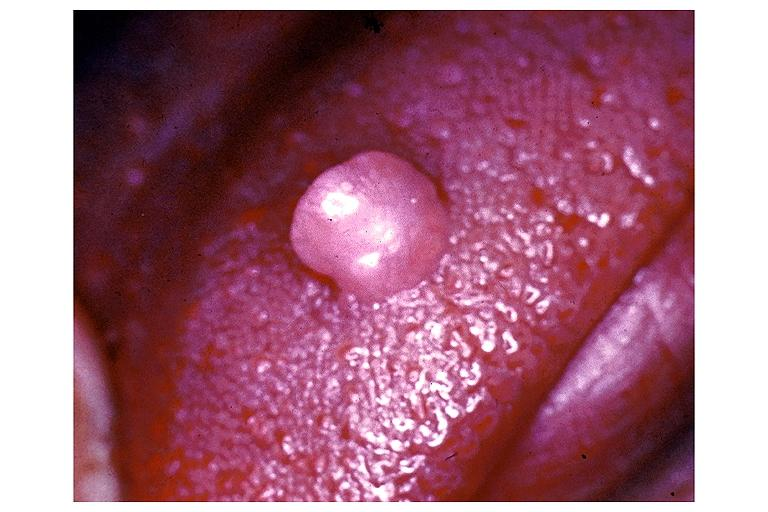where is this?
Answer the question using a single word or phrase. Oral 